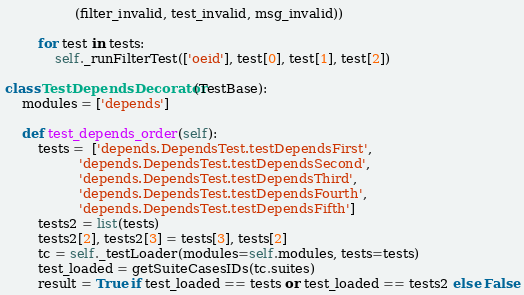<code> <loc_0><loc_0><loc_500><loc_500><_Python_>                 (filter_invalid, test_invalid, msg_invalid))

        for test in tests:
            self._runFilterTest(['oeid'], test[0], test[1], test[2])

class TestDependsDecorator(TestBase):
    modules = ['depends']

    def test_depends_order(self):
        tests =  ['depends.DependsTest.testDependsFirst',
                  'depends.DependsTest.testDependsSecond',
                  'depends.DependsTest.testDependsThird',
                  'depends.DependsTest.testDependsFourth',
                  'depends.DependsTest.testDependsFifth']
        tests2 = list(tests)
        tests2[2], tests2[3] = tests[3], tests[2]
        tc = self._testLoader(modules=self.modules, tests=tests)
        test_loaded = getSuiteCasesIDs(tc.suites)
        result = True if test_loaded == tests or test_loaded == tests2 else False</code> 